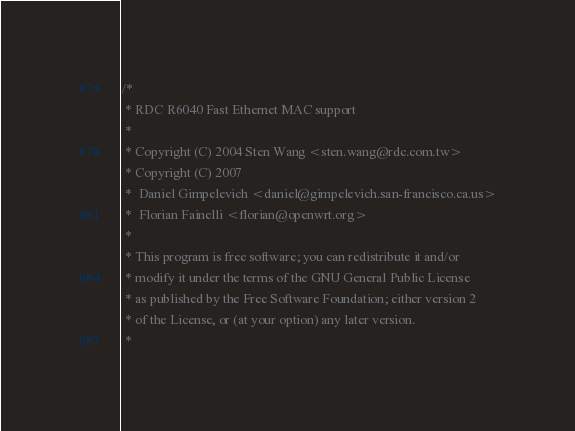<code> <loc_0><loc_0><loc_500><loc_500><_C_>/*
 * RDC R6040 Fast Ethernet MAC support
 *
 * Copyright (C) 2004 Sten Wang <sten.wang@rdc.com.tw>
 * Copyright (C) 2007
 *	Daniel Gimpelevich <daniel@gimpelevich.san-francisco.ca.us>
 *	Florian Fainelli <florian@openwrt.org>
 *
 * This program is free software; you can redistribute it and/or
 * modify it under the terms of the GNU General Public License
 * as published by the Free Software Foundation; either version 2
 * of the License, or (at your option) any later version.
 *</code> 